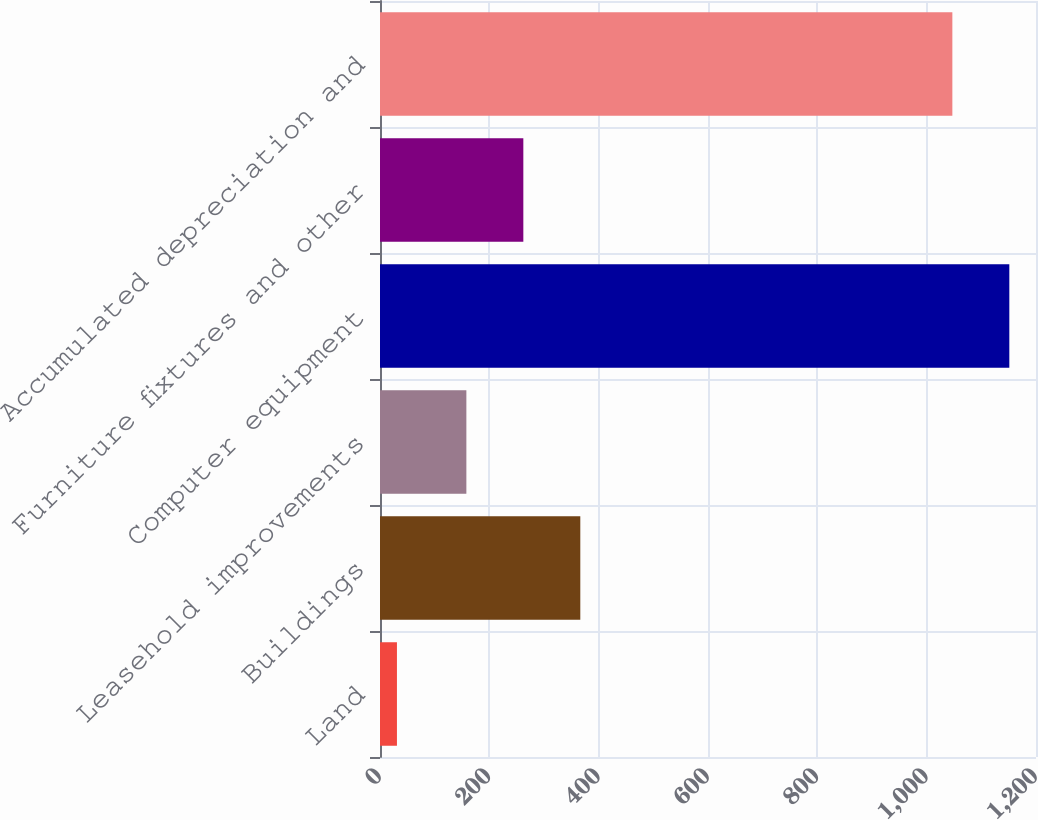Convert chart. <chart><loc_0><loc_0><loc_500><loc_500><bar_chart><fcel>Land<fcel>Buildings<fcel>Leasehold improvements<fcel>Computer equipment<fcel>Furniture fixtures and other<fcel>Accumulated depreciation and<nl><fcel>31<fcel>366.4<fcel>158<fcel>1151.2<fcel>262.2<fcel>1047<nl></chart> 